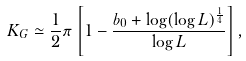Convert formula to latex. <formula><loc_0><loc_0><loc_500><loc_500>K _ { G } \simeq \frac { 1 } { 2 } \pi \left [ 1 - \frac { b _ { 0 } + \log ( \log L ) ^ { \frac { 1 } { 4 } } } { \log L } \right ] ,</formula> 